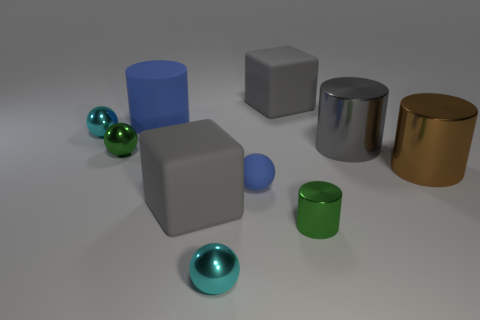How many objects are either large cylinders or small red matte spheres?
Offer a very short reply. 3. What is the size of the sphere that is the same color as the matte cylinder?
Provide a short and direct response. Small. There is a small rubber sphere; are there any brown things in front of it?
Your answer should be very brief. No. Are there more cyan metal spheres behind the brown metallic thing than brown cylinders behind the green ball?
Offer a terse response. Yes. The gray shiny object that is the same shape as the large brown metal thing is what size?
Make the answer very short. Large. What number of cubes are tiny blue things or big gray objects?
Your response must be concise. 2. There is a ball that is the same color as the rubber cylinder; what material is it?
Give a very brief answer. Rubber. Are there fewer cyan metal balls that are behind the tiny blue rubber sphere than brown metallic objects in front of the green metallic cylinder?
Offer a very short reply. No. How many objects are either large gray rubber blocks behind the large brown metal object or tiny brown matte blocks?
Ensure brevity in your answer.  1. The big gray thing that is left of the gray matte block that is behind the tiny blue matte ball is what shape?
Provide a short and direct response. Cube. 